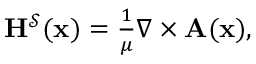<formula> <loc_0><loc_0><loc_500><loc_500>\begin{array} { r } { H ^ { \mathcal { S } } ( x ) = \frac { 1 } { \mu } \nabla \times A ( x ) , } \end{array}</formula> 